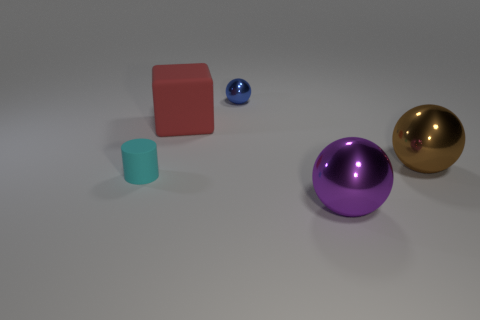Are there the same number of large red objects to the left of the big rubber cube and cyan matte cylinders?
Ensure brevity in your answer.  No. Are there any large purple objects behind the large matte object?
Give a very brief answer. No. What is the size of the ball that is left of the shiny ball in front of the large metallic object on the right side of the big purple object?
Keep it short and to the point. Small. There is a big object on the left side of the tiny blue ball; is its shape the same as the small object behind the brown shiny thing?
Give a very brief answer. No. The purple metallic thing that is the same shape as the small blue thing is what size?
Your response must be concise. Large. What number of blue balls have the same material as the brown thing?
Ensure brevity in your answer.  1. What is the material of the purple sphere?
Ensure brevity in your answer.  Metal. There is a tiny object on the left side of the tiny thing to the right of the tiny cyan object; what shape is it?
Provide a succinct answer. Cylinder. What is the shape of the matte thing in front of the big brown thing?
Your response must be concise. Cylinder. How many things have the same color as the small ball?
Make the answer very short. 0. 